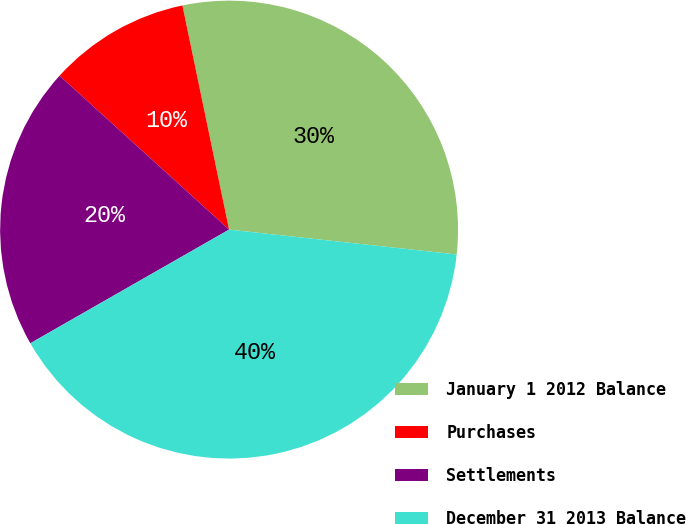Convert chart to OTSL. <chart><loc_0><loc_0><loc_500><loc_500><pie_chart><fcel>January 1 2012 Balance<fcel>Purchases<fcel>Settlements<fcel>December 31 2013 Balance<nl><fcel>30.0%<fcel>10.0%<fcel>20.0%<fcel>40.0%<nl></chart> 